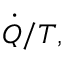Convert formula to latex. <formula><loc_0><loc_0><loc_500><loc_500>{ \dot { Q } } / T ,</formula> 